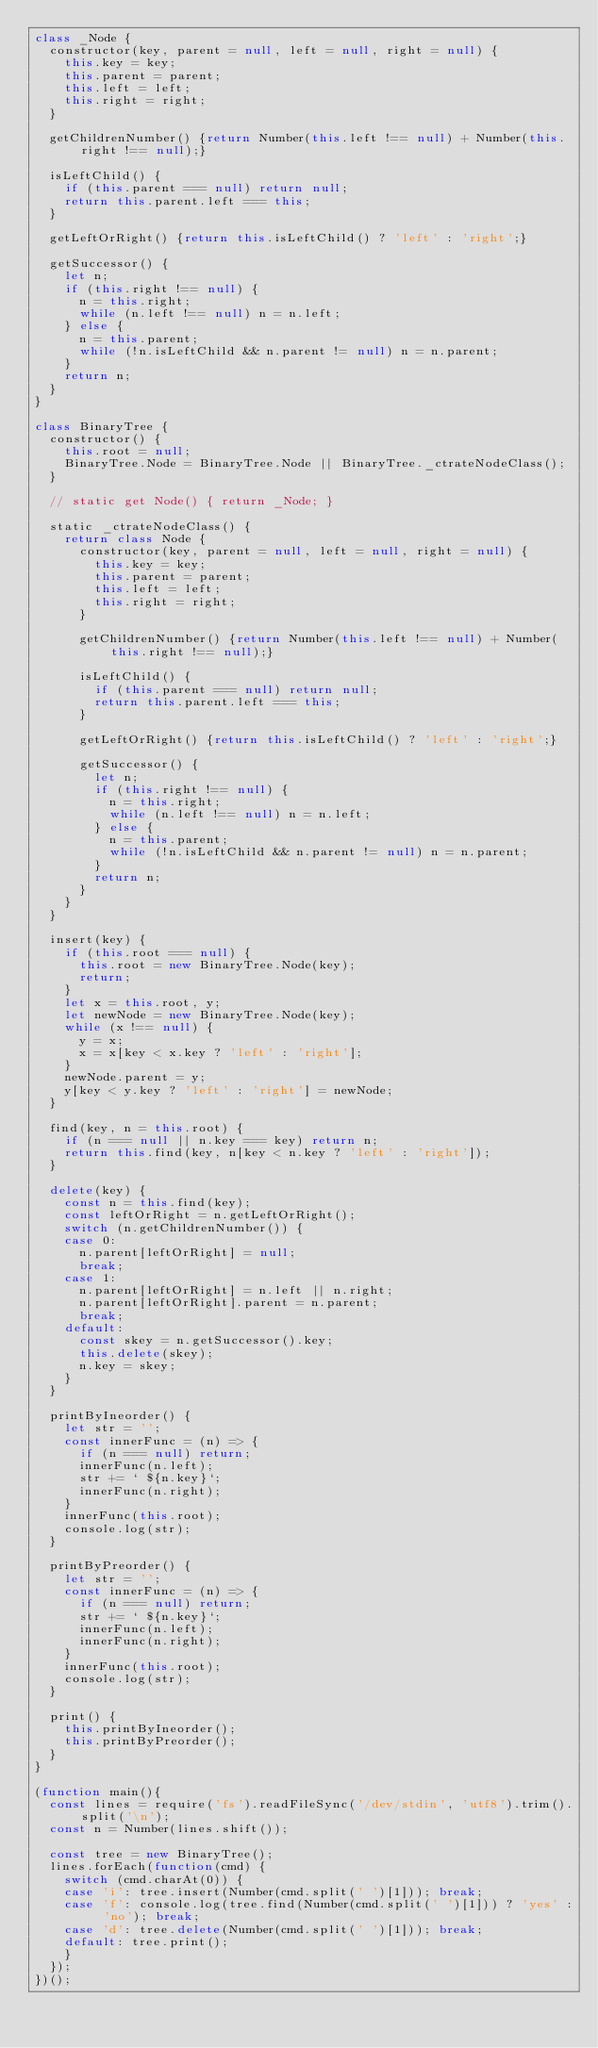Convert code to text. <code><loc_0><loc_0><loc_500><loc_500><_JavaScript_>class _Node {
  constructor(key, parent = null, left = null, right = null) {
    this.key = key;
    this.parent = parent;
    this.left = left;
    this.right = right;
  }

  getChildrenNumber() {return Number(this.left !== null) + Number(this.right !== null);}

  isLeftChild() {
    if (this.parent === null) return null;
    return this.parent.left === this;
  }

  getLeftOrRight() {return this.isLeftChild() ? 'left' : 'right';}

  getSuccessor() {
    let n;
    if (this.right !== null) {
      n = this.right;
      while (n.left !== null) n = n.left;
    } else {
      n = this.parent;
      while (!n.isLeftChild && n.parent != null) n = n.parent;
    }
    return n;
  }
}

class BinaryTree {
  constructor() {
    this.root = null;
    BinaryTree.Node = BinaryTree.Node || BinaryTree._ctrateNodeClass();
  }

  // static get Node() { return _Node; }

  static _ctrateNodeClass() {
    return class Node {
      constructor(key, parent = null, left = null, right = null) {
        this.key = key;
        this.parent = parent;
        this.left = left;
        this.right = right;
      }

      getChildrenNumber() {return Number(this.left !== null) + Number(this.right !== null);}

      isLeftChild() {
        if (this.parent === null) return null;
        return this.parent.left === this;
      }

      getLeftOrRight() {return this.isLeftChild() ? 'left' : 'right';}

      getSuccessor() {
        let n;
        if (this.right !== null) {
          n = this.right;
          while (n.left !== null) n = n.left;
        } else {
          n = this.parent;
          while (!n.isLeftChild && n.parent != null) n = n.parent;
        }
        return n;
      }
    }
  }

  insert(key) {
    if (this.root === null) {
      this.root = new BinaryTree.Node(key);
      return;
    }
    let x = this.root, y;
    let newNode = new BinaryTree.Node(key);
    while (x !== null) {
      y = x;
      x = x[key < x.key ? 'left' : 'right'];
    }
    newNode.parent = y;
    y[key < y.key ? 'left' : 'right'] = newNode;
  }

  find(key, n = this.root) {
    if (n === null || n.key === key) return n;
    return this.find(key, n[key < n.key ? 'left' : 'right']);
  }

  delete(key) {
    const n = this.find(key);
    const leftOrRight = n.getLeftOrRight();
    switch (n.getChildrenNumber()) {
    case 0:
      n.parent[leftOrRight] = null;
      break;
    case 1:
      n.parent[leftOrRight] = n.left || n.right;
      n.parent[leftOrRight].parent = n.parent;
      break;
    default:
      const skey = n.getSuccessor().key;
      this.delete(skey);
      n.key = skey;
    }
  }

  printByIneorder() {
    let str = '';
    const innerFunc = (n) => {
      if (n === null) return;
      innerFunc(n.left);
      str += ` ${n.key}`;
      innerFunc(n.right);
    }
    innerFunc(this.root);
    console.log(str);
  }

  printByPreorder() {
    let str = '';
    const innerFunc = (n) => {
      if (n === null) return;
      str += ` ${n.key}`;
      innerFunc(n.left);
      innerFunc(n.right);
    }
    innerFunc(this.root);
    console.log(str);
  }

  print() {
    this.printByIneorder();
    this.printByPreorder();
  }
}

(function main(){
  const lines = require('fs').readFileSync('/dev/stdin', 'utf8').trim().split('\n');
  const n = Number(lines.shift());

  const tree = new BinaryTree();
  lines.forEach(function(cmd) {
    switch (cmd.charAt(0)) {
    case 'i': tree.insert(Number(cmd.split(' ')[1])); break;
    case 'f': console.log(tree.find(Number(cmd.split(' ')[1])) ? 'yes' : 'no'); break;
    case 'd': tree.delete(Number(cmd.split(' ')[1])); break;
    default: tree.print();
    }
  });
})();

</code> 